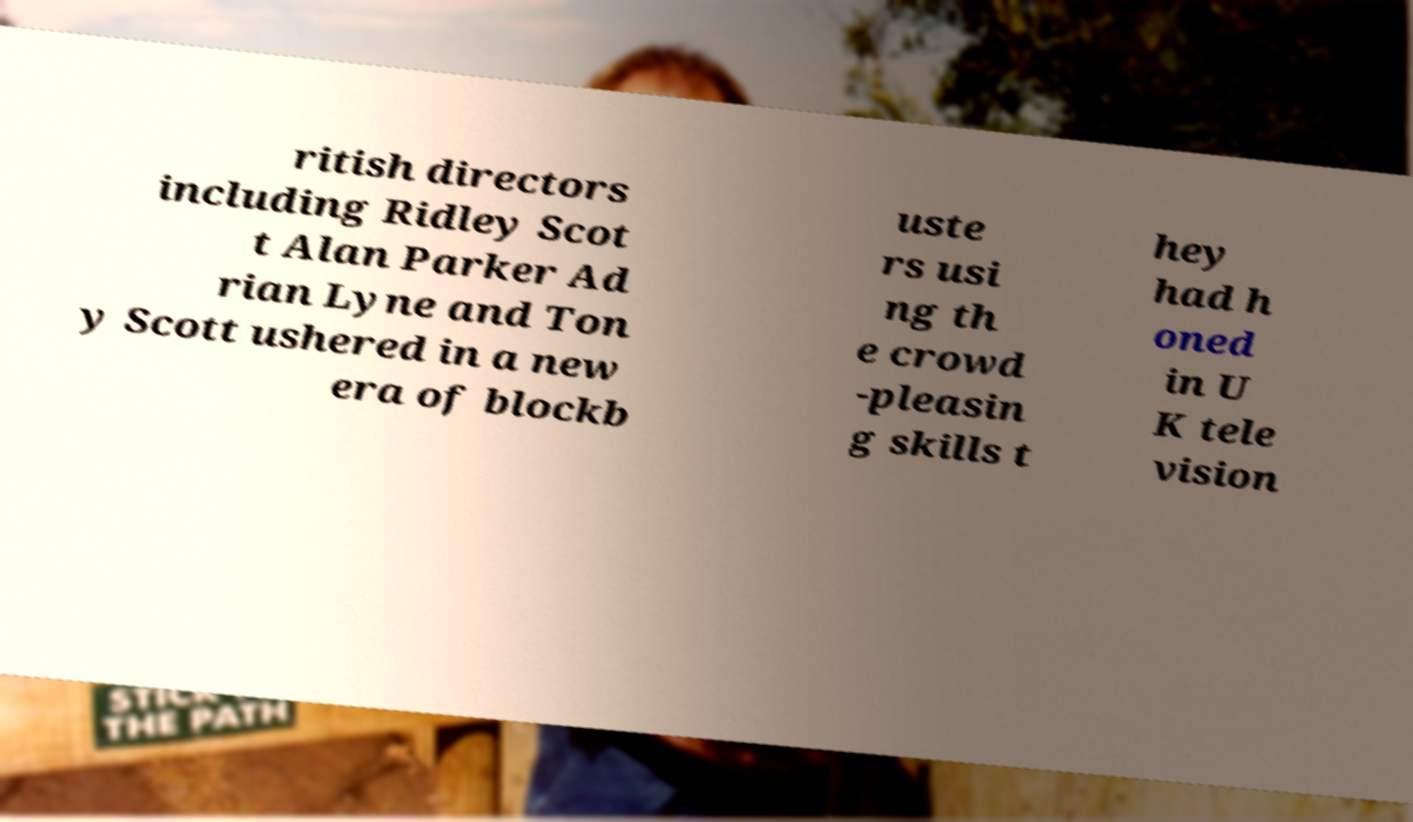Can you read and provide the text displayed in the image?This photo seems to have some interesting text. Can you extract and type it out for me? ritish directors including Ridley Scot t Alan Parker Ad rian Lyne and Ton y Scott ushered in a new era of blockb uste rs usi ng th e crowd -pleasin g skills t hey had h oned in U K tele vision 